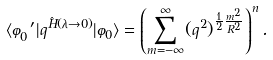<formula> <loc_0><loc_0><loc_500><loc_500>\langle \varphi ^ { \prime } _ { 0 } | q ^ { \hat { H } ( \lambda \rightarrow 0 ) } | \varphi _ { 0 } \rangle = \left ( \sum _ { m = - \infty } ^ { \infty } ( q ^ { 2 } ) ^ { \frac { 1 } { 2 } \frac { m ^ { 2 } } { R ^ { 2 } } } \right ) ^ { n } .</formula> 